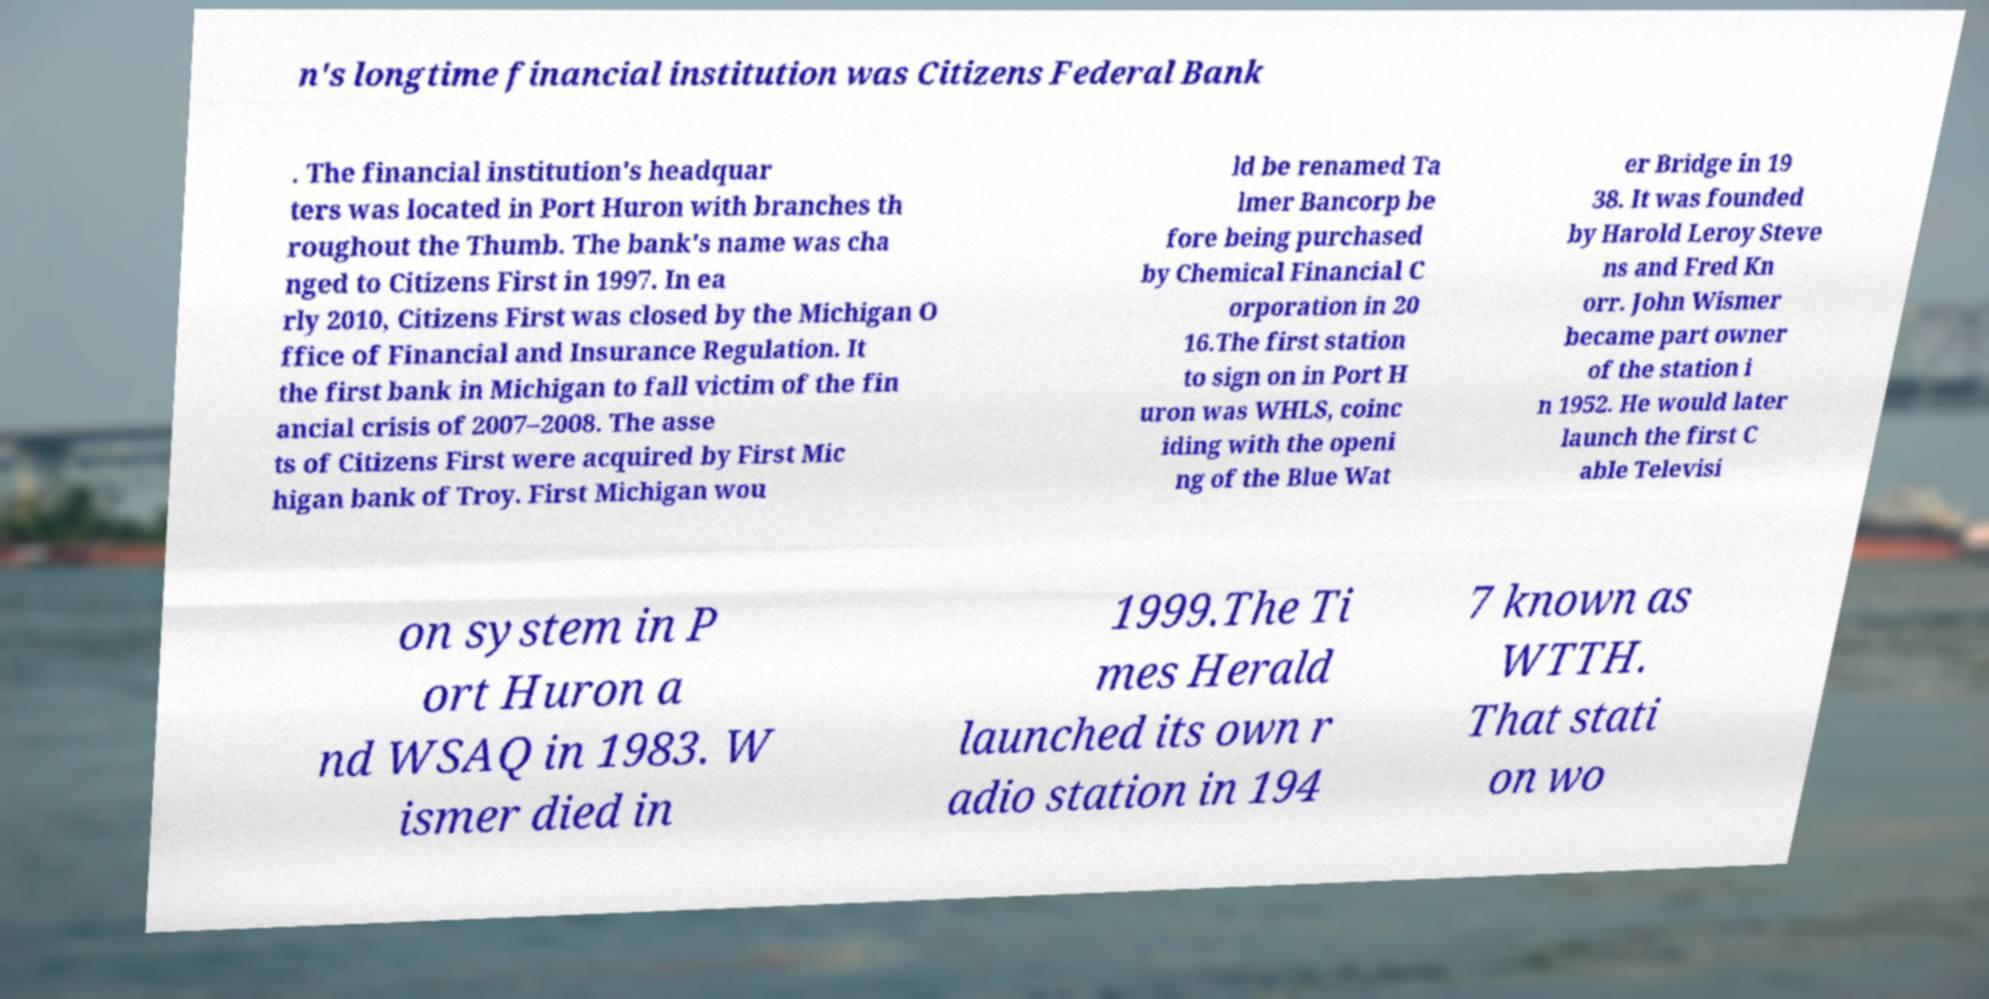Can you accurately transcribe the text from the provided image for me? n's longtime financial institution was Citizens Federal Bank . The financial institution's headquar ters was located in Port Huron with branches th roughout the Thumb. The bank's name was cha nged to Citizens First in 1997. In ea rly 2010, Citizens First was closed by the Michigan O ffice of Financial and Insurance Regulation. It the first bank in Michigan to fall victim of the fin ancial crisis of 2007–2008. The asse ts of Citizens First were acquired by First Mic higan bank of Troy. First Michigan wou ld be renamed Ta lmer Bancorp be fore being purchased by Chemical Financial C orporation in 20 16.The first station to sign on in Port H uron was WHLS, coinc iding with the openi ng of the Blue Wat er Bridge in 19 38. It was founded by Harold Leroy Steve ns and Fred Kn orr. John Wismer became part owner of the station i n 1952. He would later launch the first C able Televisi on system in P ort Huron a nd WSAQ in 1983. W ismer died in 1999.The Ti mes Herald launched its own r adio station in 194 7 known as WTTH. That stati on wo 